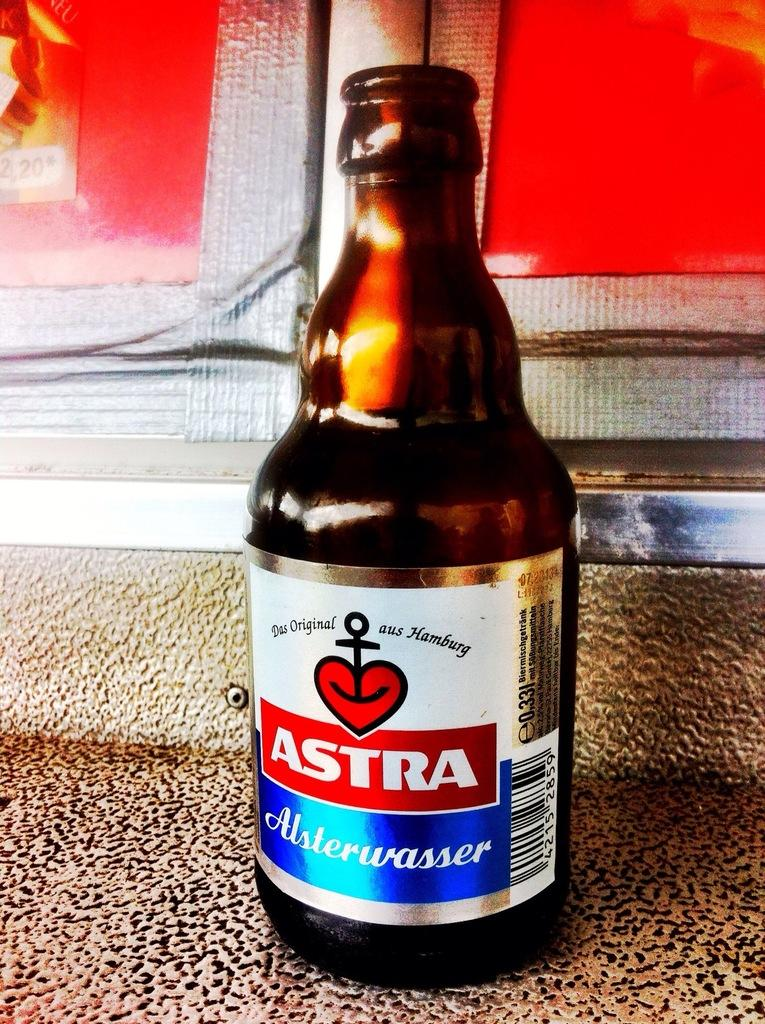<image>
Share a concise interpretation of the image provided. A bottle of Astra Alsterwasser sits on a countertop. 